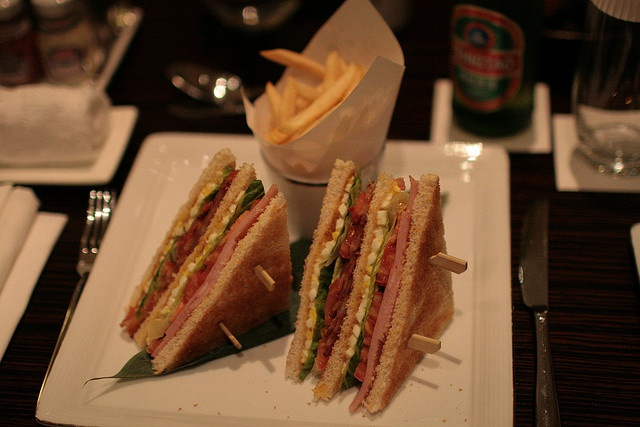Describe the objects in this image and their specific colors. I can see dining table in black, brown, tan, and maroon tones, sandwich in gray, brown, maroon, and tan tones, sandwich in gray, brown, maroon, black, and salmon tones, bottle in gray, black, maroon, and darkgreen tones, and cup in gray, black, and maroon tones in this image. 